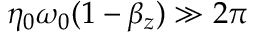Convert formula to latex. <formula><loc_0><loc_0><loc_500><loc_500>\eta _ { 0 } \omega _ { 0 } ( 1 - \beta _ { z } ) \gg 2 \pi</formula> 